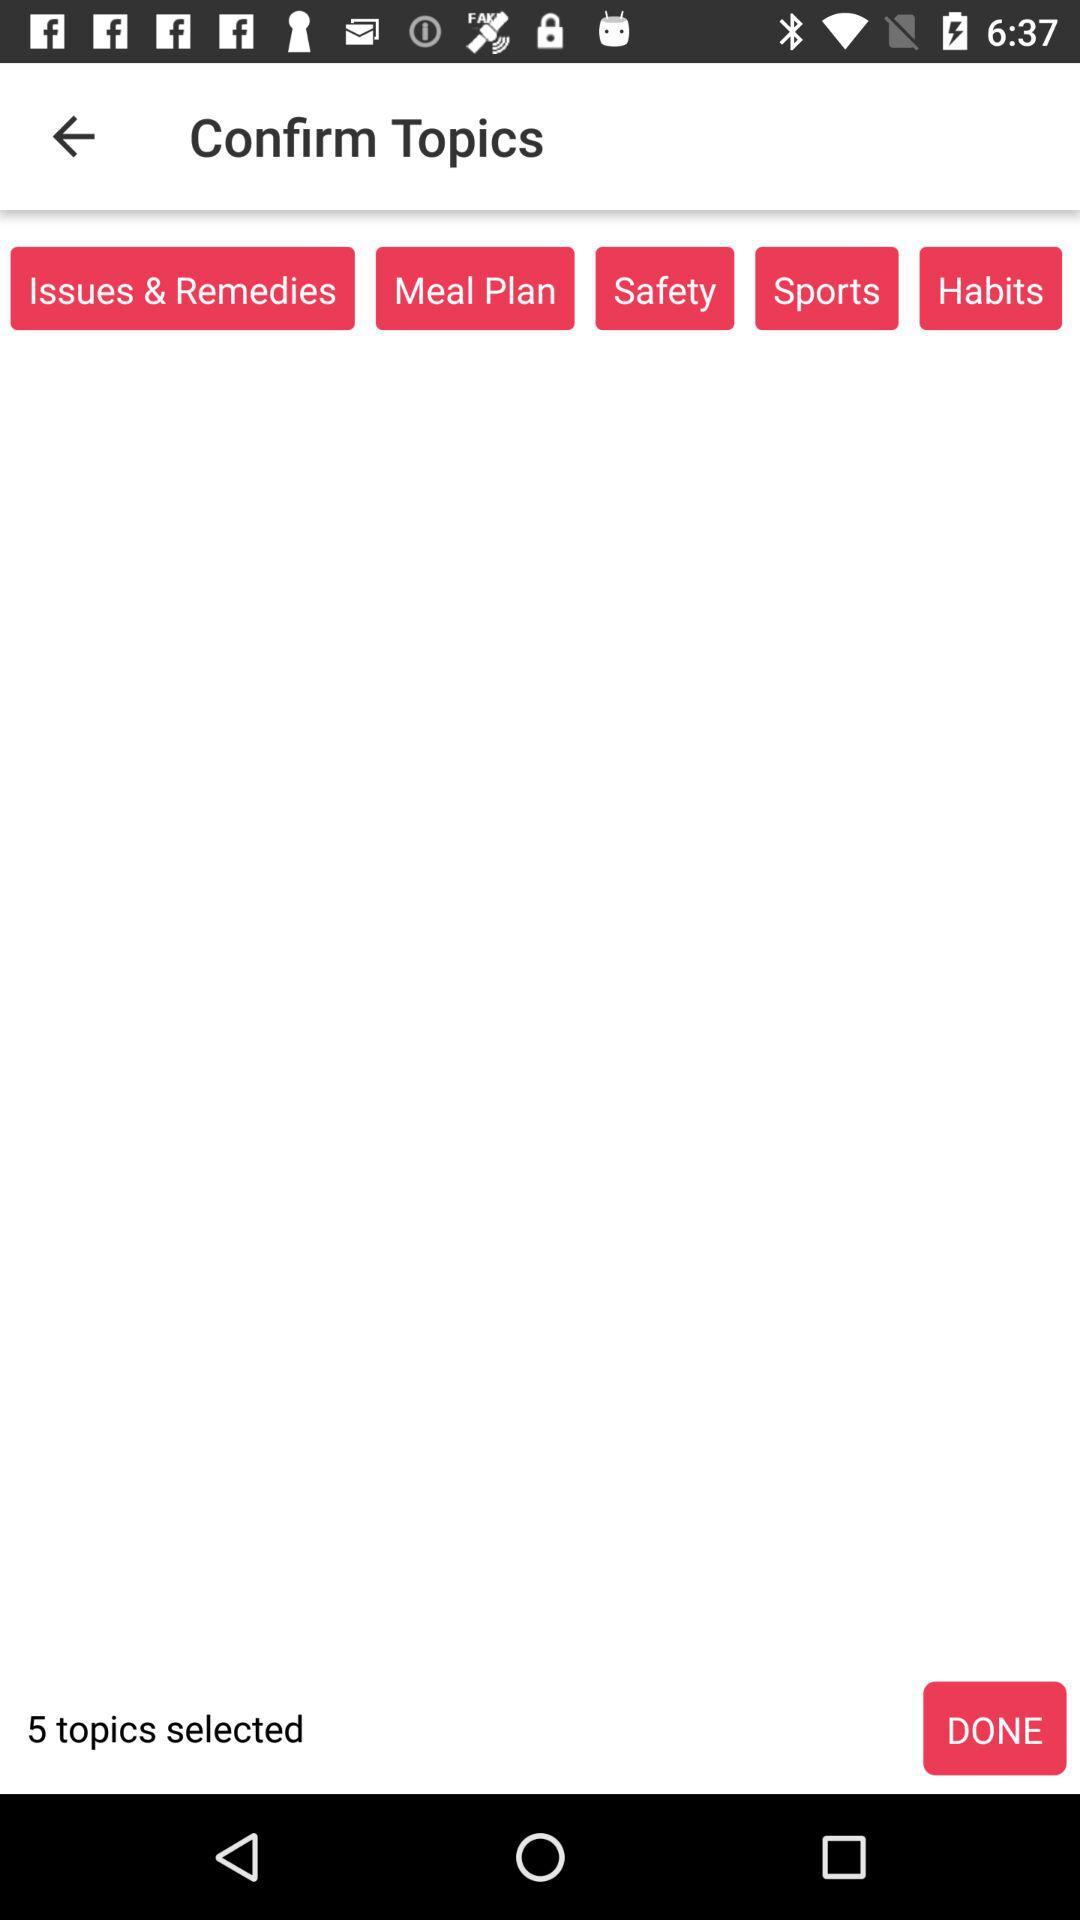How many topics are selected?
Answer the question using a single word or phrase. 5 